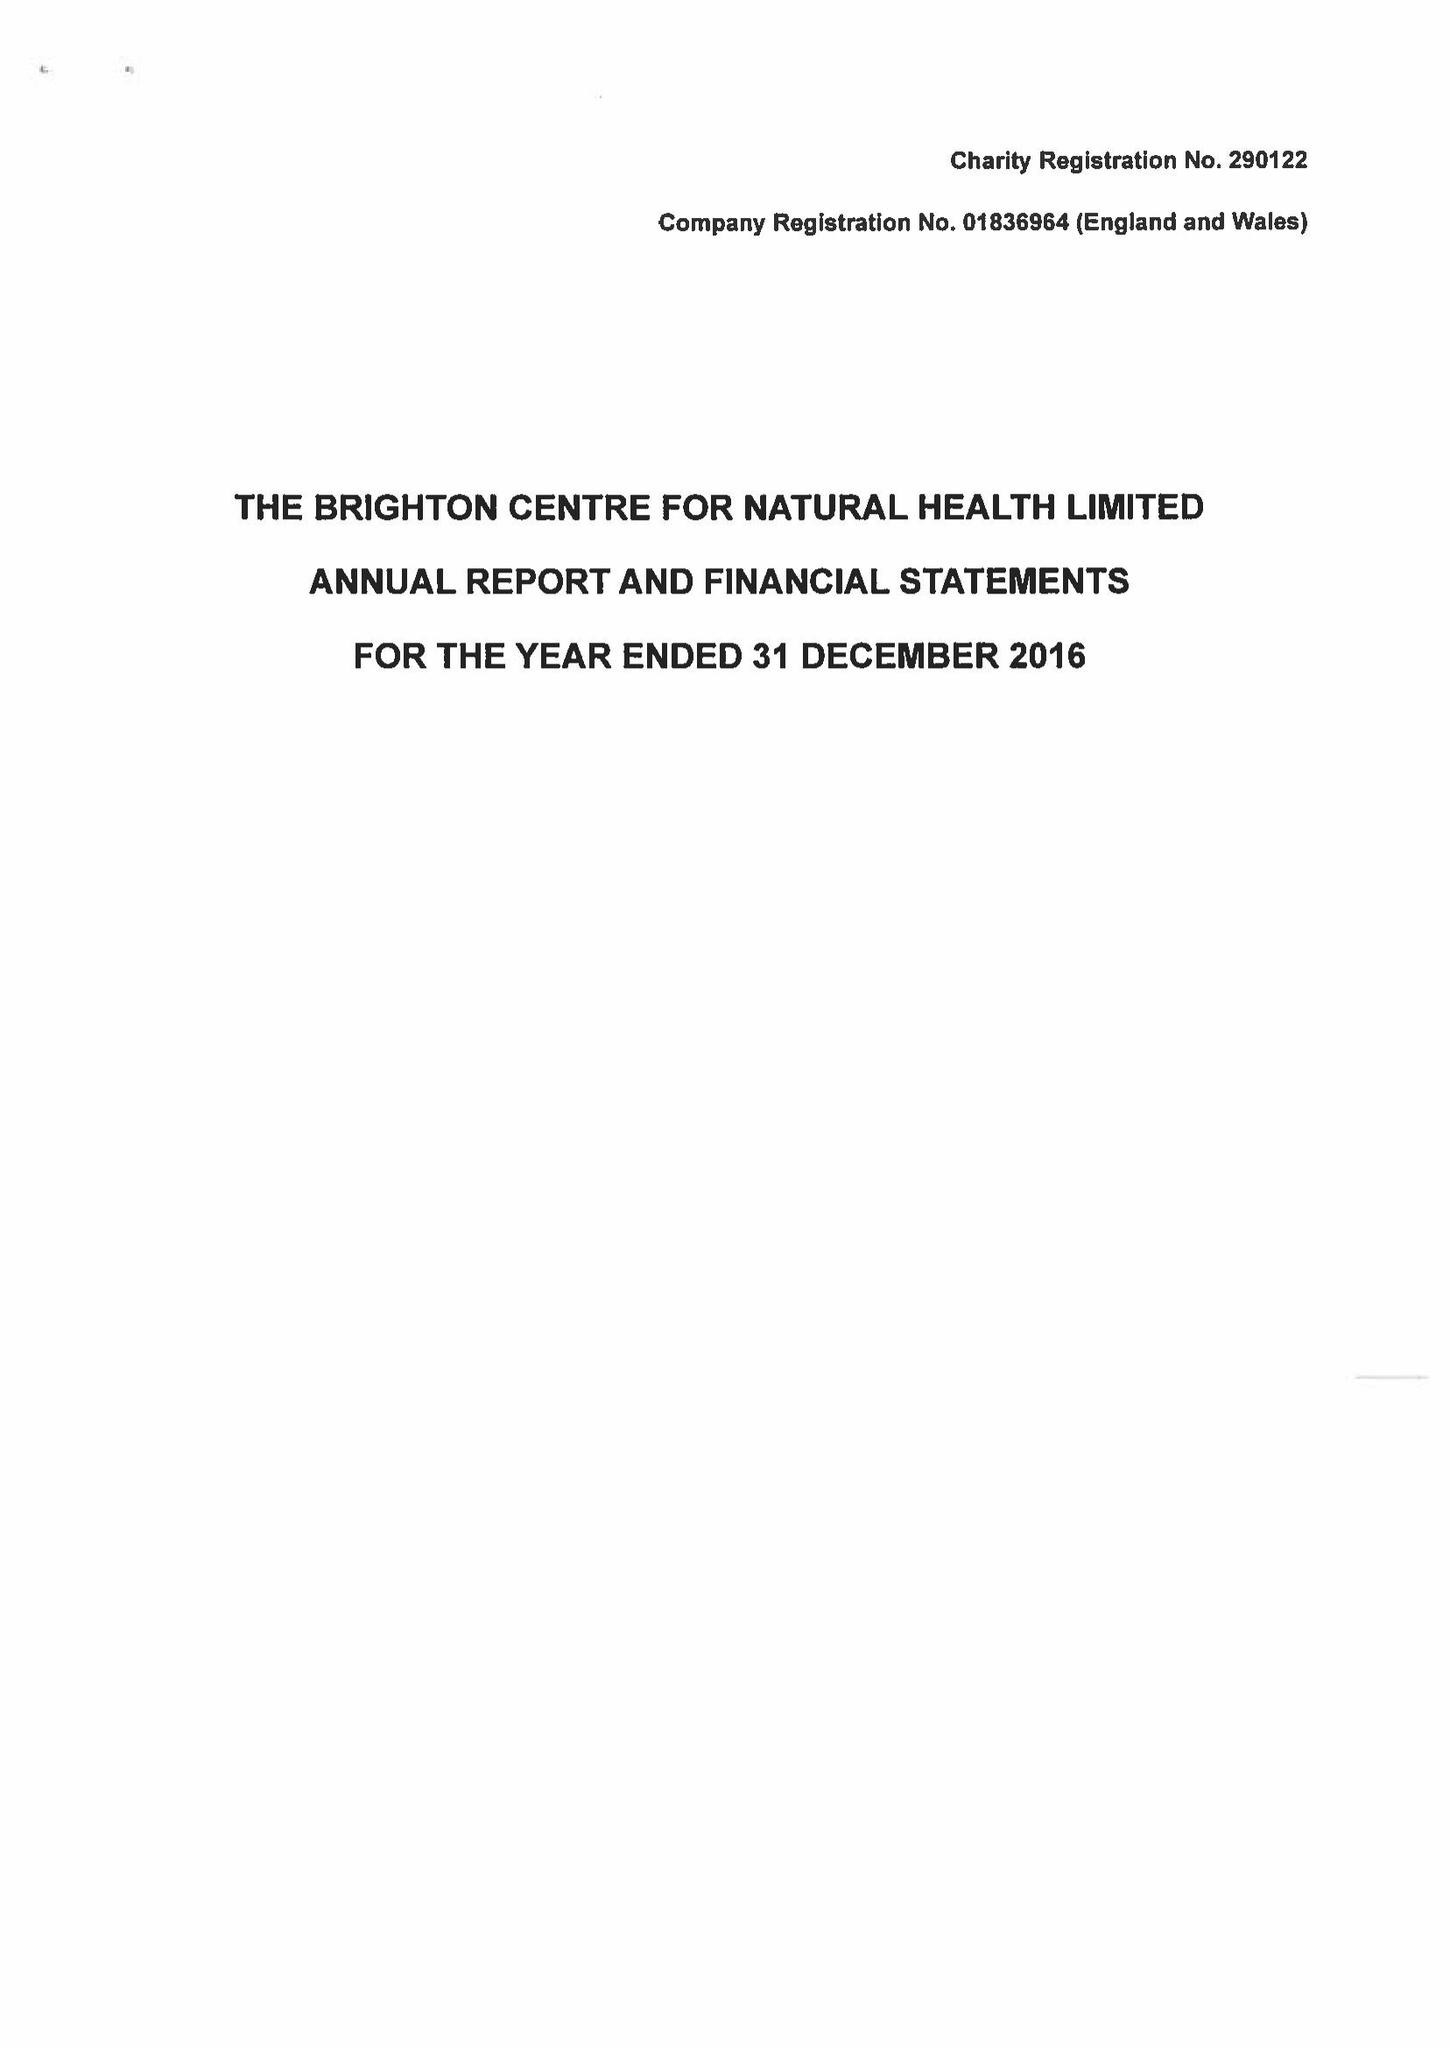What is the value for the address__post_town?
Answer the question using a single word or phrase. BRIGHTON 